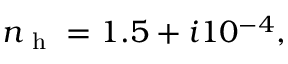Convert formula to latex. <formula><loc_0><loc_0><loc_500><loc_500>n _ { h } = 1 . 5 + i 1 0 ^ { - 4 } ,</formula> 